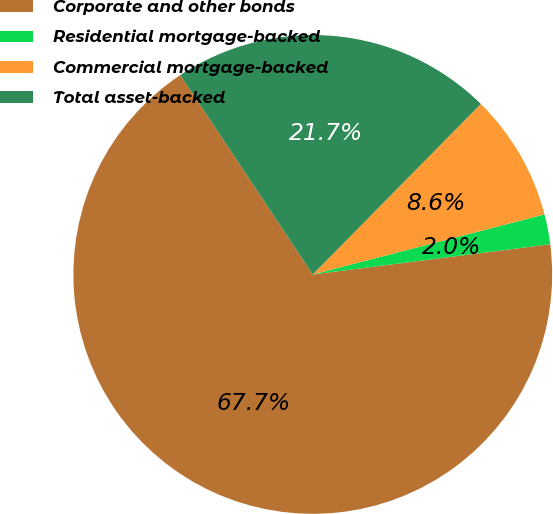<chart> <loc_0><loc_0><loc_500><loc_500><pie_chart><fcel>Corporate and other bonds<fcel>Residential mortgage-backed<fcel>Commercial mortgage-backed<fcel>Total asset-backed<nl><fcel>67.68%<fcel>2.02%<fcel>8.58%<fcel>21.72%<nl></chart> 